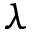<formula> <loc_0><loc_0><loc_500><loc_500>\lambda</formula> 